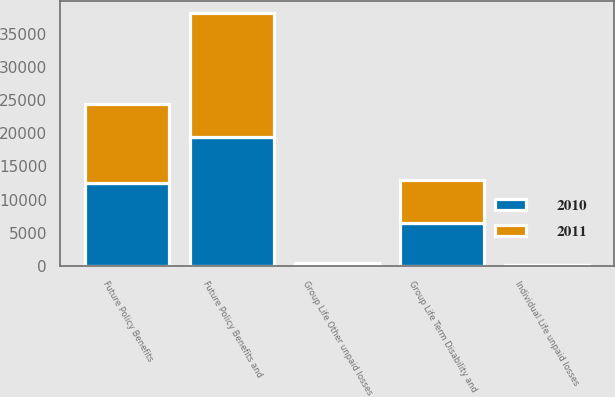Convert chart to OTSL. <chart><loc_0><loc_0><loc_500><loc_500><stacked_bar_chart><ecel><fcel>Group Life Term Disability and<fcel>Group Life Other unpaid losses<fcel>Individual Life unpaid losses<fcel>Future Policy Benefits<fcel>Future Policy Benefits and<nl><fcel>2010<fcel>6547<fcel>213<fcel>134<fcel>12572<fcel>19466<nl><fcel>2011<fcel>6388<fcel>216<fcel>110<fcel>11859<fcel>18573<nl></chart> 